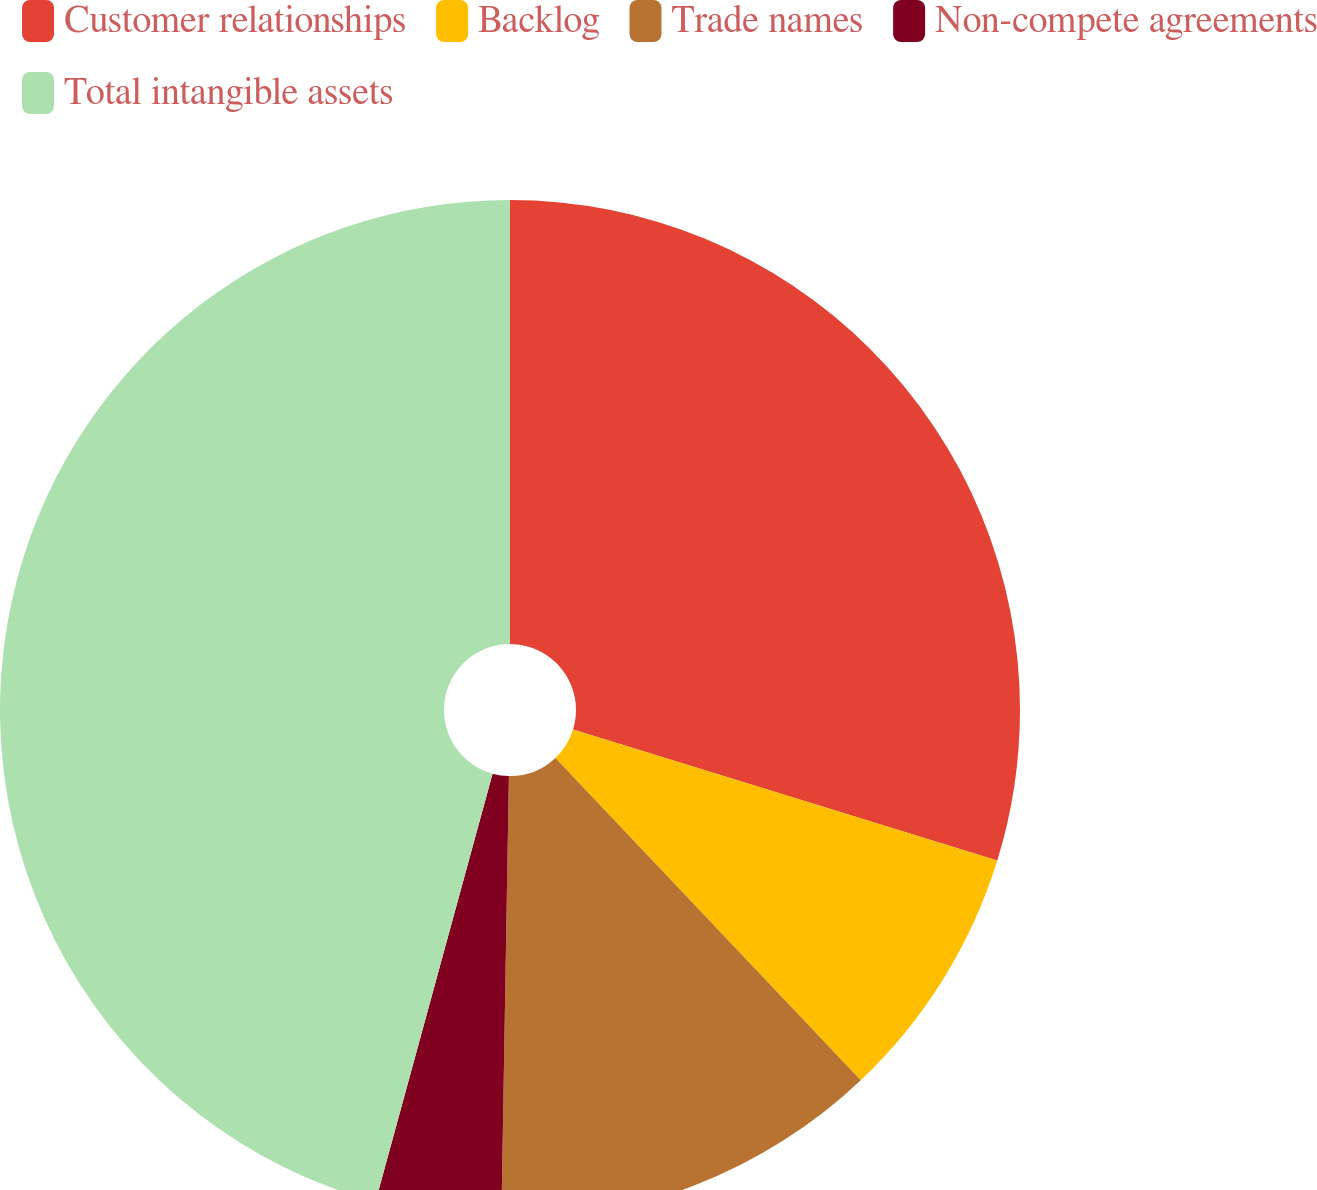Convert chart. <chart><loc_0><loc_0><loc_500><loc_500><pie_chart><fcel>Customer relationships<fcel>Backlog<fcel>Trade names<fcel>Non-compete agreements<fcel>Total intangible assets<nl><fcel>29.77%<fcel>8.16%<fcel>12.34%<fcel>3.98%<fcel>45.75%<nl></chart> 